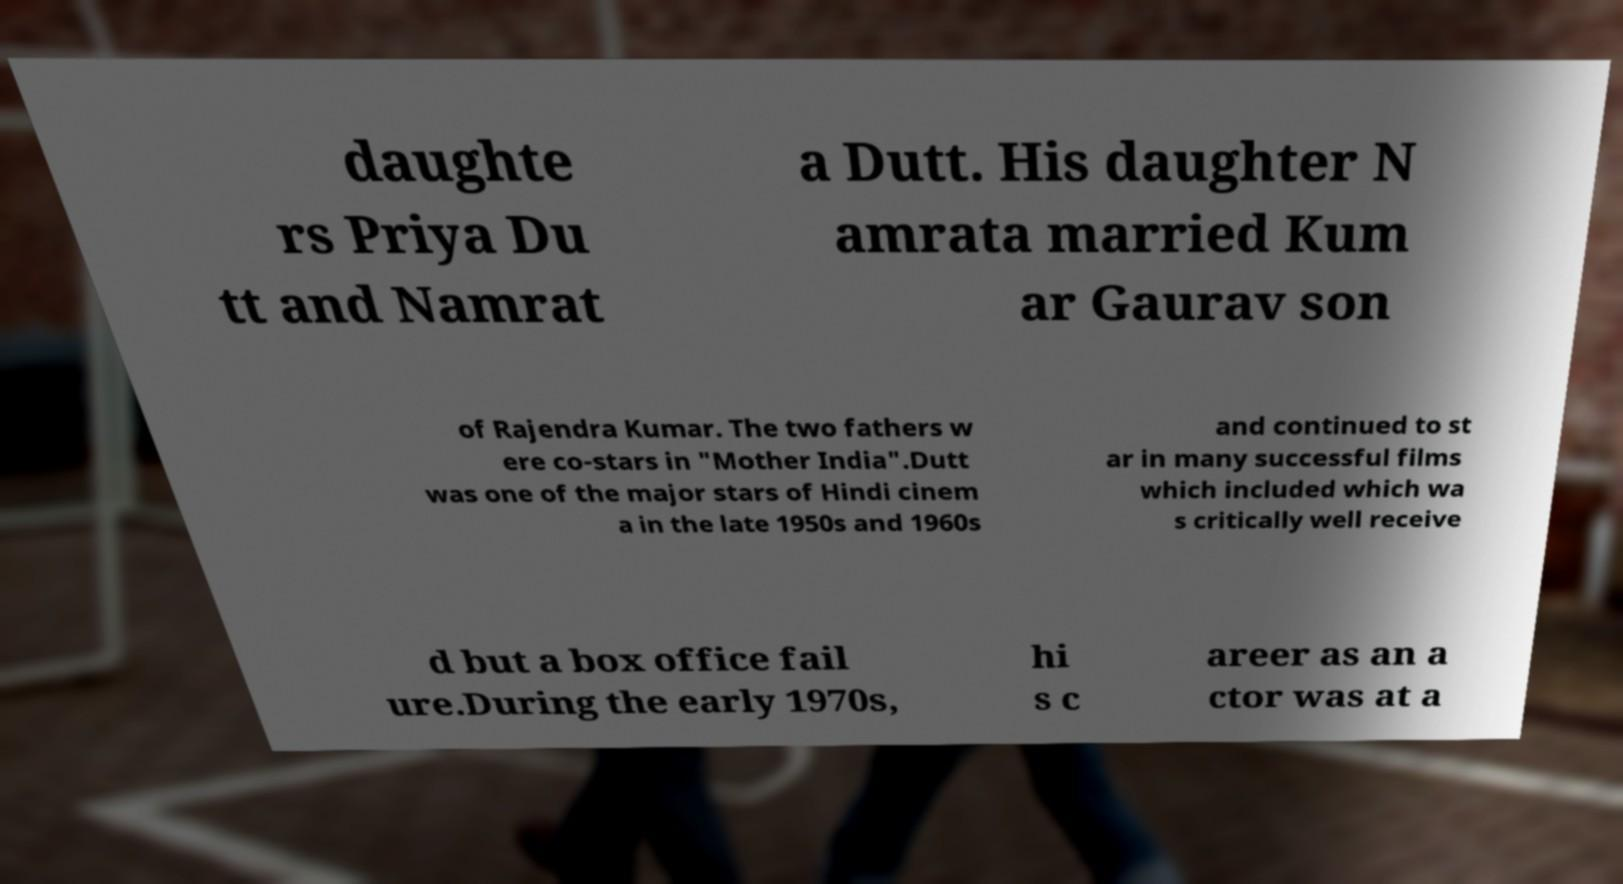Can you accurately transcribe the text from the provided image for me? daughte rs Priya Du tt and Namrat a Dutt. His daughter N amrata married Kum ar Gaurav son of Rajendra Kumar. The two fathers w ere co-stars in "Mother India".Dutt was one of the major stars of Hindi cinem a in the late 1950s and 1960s and continued to st ar in many successful films which included which wa s critically well receive d but a box office fail ure.During the early 1970s, hi s c areer as an a ctor was at a 